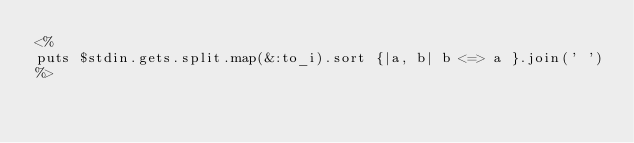<code> <loc_0><loc_0><loc_500><loc_500><_Ruby_><%
puts $stdin.gets.split.map(&:to_i).sort {|a, b| b <=> a }.join(' ')
%></code> 